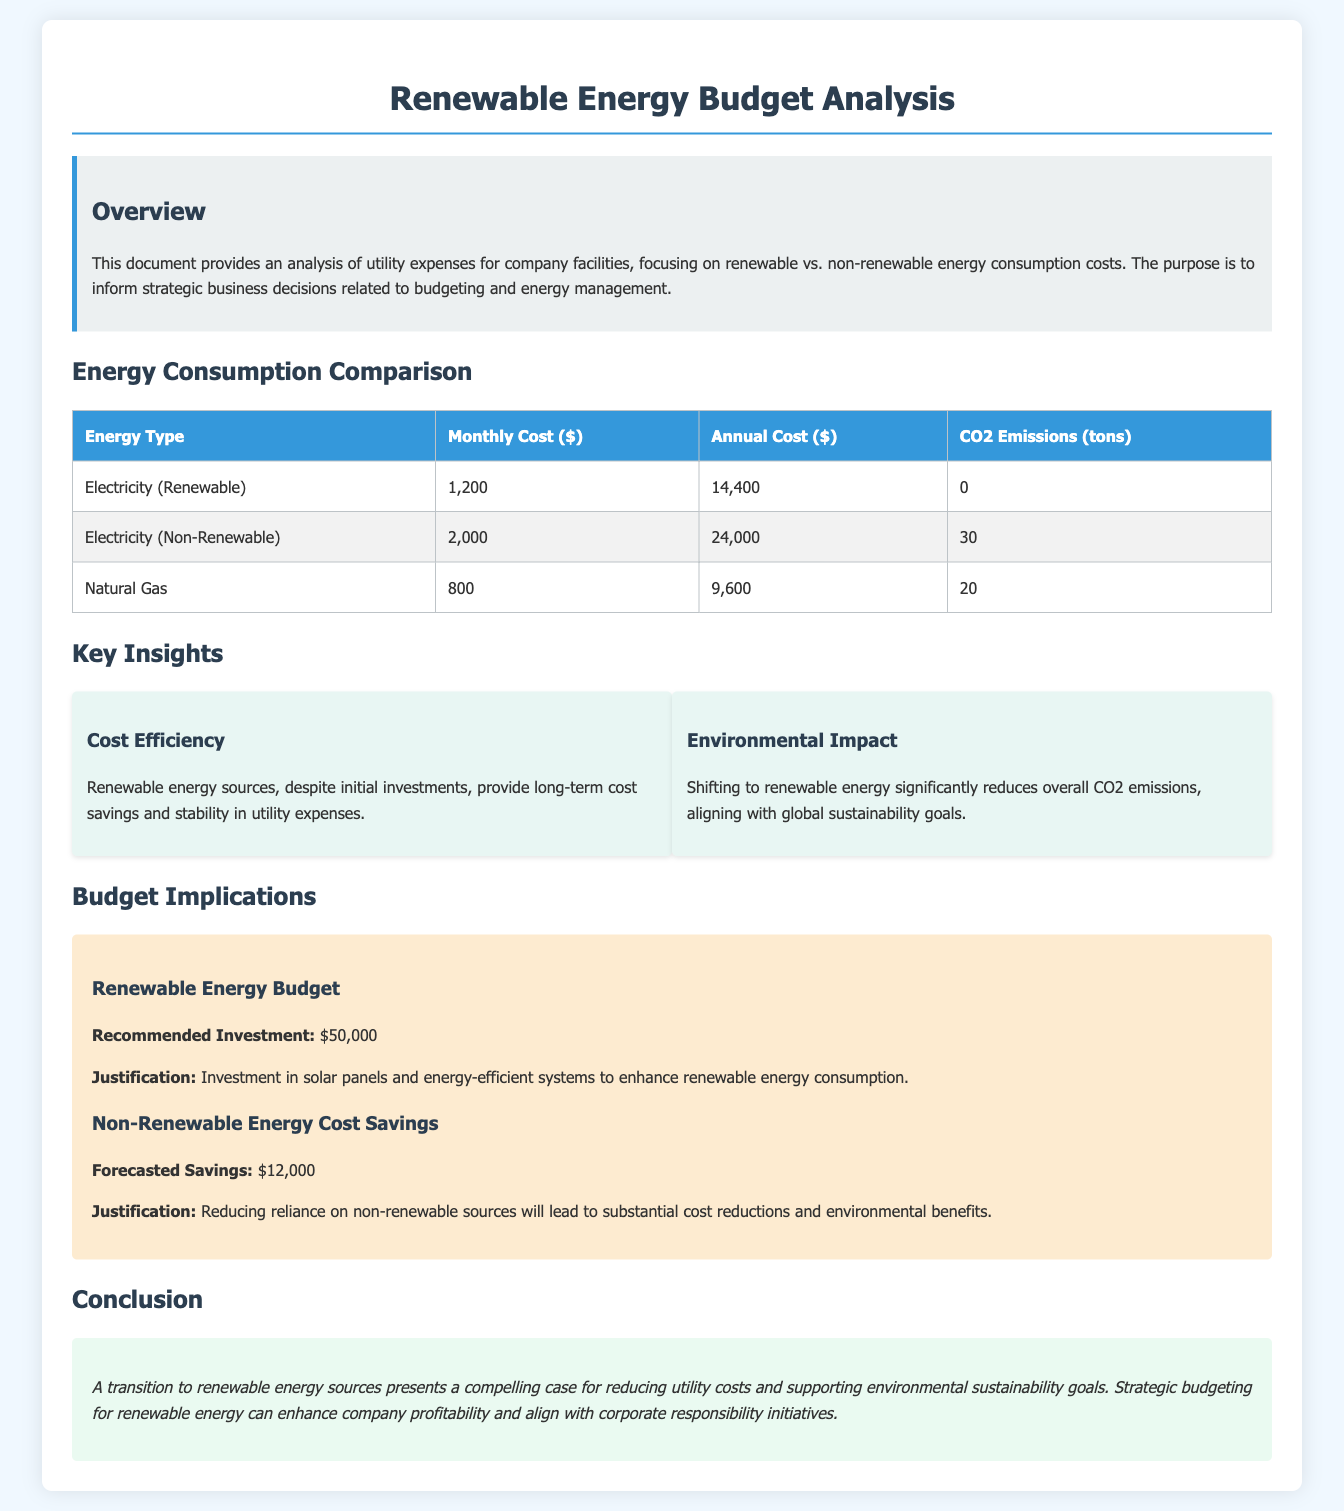What is the monthly cost for renewable electricity? The monthly cost for renewable electricity is stated in the document under the "Energy Consumption Comparison" section.
Answer: 1,200 What is the annual cost for non-renewable electricity? The annual cost for non-renewable electricity can be found in the same section of the document as above.
Answer: 24,000 How many tons of CO2 emissions are produced from natural gas? The CO2 emissions for natural gas are listed in the "Energy Consumption Comparison" table.
Answer: 20 What is the recommended investment for renewable energy? The recommended investment for renewable energy can be found in the "Budget Implications" section of the document.
Answer: 50,000 What is the forecasted savings from reducing non-renewable energy reliance? The forecasted savings from reducing non-renewable energy is mentioned in the "Budget Implications" section.
Answer: 12,000 What is the main justification for the recommended investment? The justification for the recommended investment is found in the "Budget Implications" section detailing the purpose of the investment.
Answer: Investment in solar panels and energy-efficient systems What does the document conclude about transitioning to renewable energy? The conclusion summarizes the benefits of transitioning to renewable energy as stated in the conclusion section.
Answer: Reducing utility costs and supporting environmental sustainability goals What are the key insights regarding cost efficiency? The key insight related to cost efficiency explains the benefits of renewable energy found under "Key Insights."
Answer: Long-term cost savings and stability What are the implications of shifting to renewable energy on CO2 emissions? The implications of shifting to renewable energy regarding CO2 emissions are also addressed in the "Key Insights" section.
Answer: Significantly reduces overall CO2 emissions 